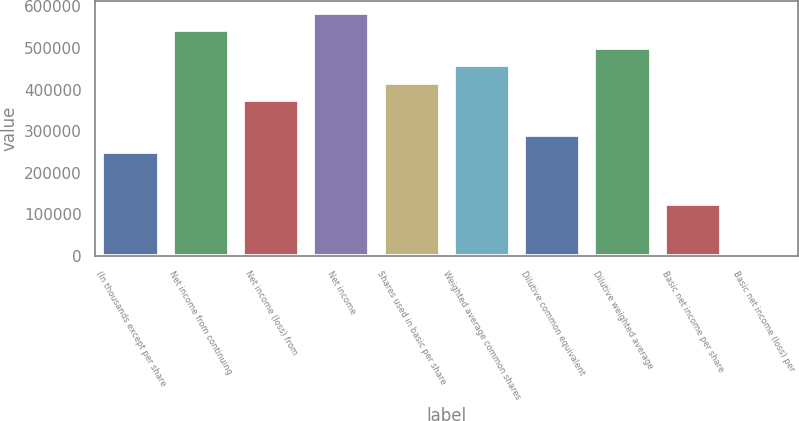Convert chart to OTSL. <chart><loc_0><loc_0><loc_500><loc_500><bar_chart><fcel>(In thousands except per share<fcel>Net income from continuing<fcel>Net income (loss) from<fcel>Net income<fcel>Shares used in basic per share<fcel>Weighted average common shares<fcel>Dilutive common equivalent<fcel>Dilutive weighted average<fcel>Basic net income per share<fcel>Basic net income (loss) per<nl><fcel>250178<fcel>542052<fcel>375267<fcel>583748<fcel>416963<fcel>458659<fcel>291874<fcel>500356<fcel>125089<fcel>0.1<nl></chart> 